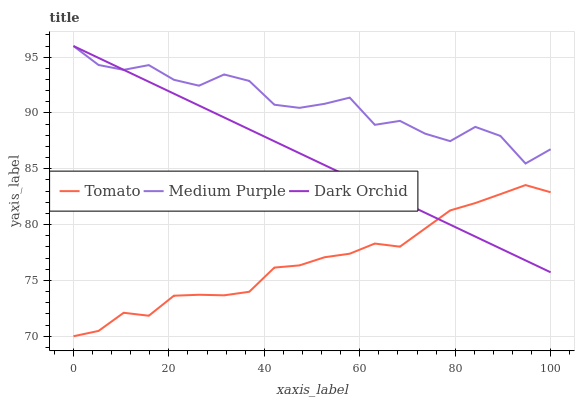Does Tomato have the minimum area under the curve?
Answer yes or no. Yes. Does Medium Purple have the maximum area under the curve?
Answer yes or no. Yes. Does Dark Orchid have the minimum area under the curve?
Answer yes or no. No. Does Dark Orchid have the maximum area under the curve?
Answer yes or no. No. Is Dark Orchid the smoothest?
Answer yes or no. Yes. Is Medium Purple the roughest?
Answer yes or no. Yes. Is Medium Purple the smoothest?
Answer yes or no. No. Is Dark Orchid the roughest?
Answer yes or no. No. Does Tomato have the lowest value?
Answer yes or no. Yes. Does Dark Orchid have the lowest value?
Answer yes or no. No. Does Dark Orchid have the highest value?
Answer yes or no. Yes. Is Tomato less than Medium Purple?
Answer yes or no. Yes. Is Medium Purple greater than Tomato?
Answer yes or no. Yes. Does Tomato intersect Dark Orchid?
Answer yes or no. Yes. Is Tomato less than Dark Orchid?
Answer yes or no. No. Is Tomato greater than Dark Orchid?
Answer yes or no. No. Does Tomato intersect Medium Purple?
Answer yes or no. No. 